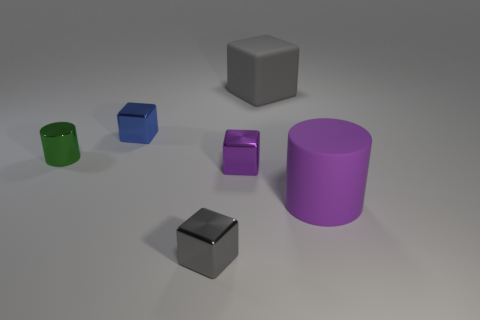Compared to the other objects, where is the green cylinder located? The green cylinder in the image is positioned on the left-hand side. It is closest to the foreground when compared to the other objects, and it is situated directly to the left of the small purple metallic cube. How would you describe its size in relation to the other objects? The green cylinder is medium-sized when compared to the other objects. It is smaller than the purple cylindrical shape and the large blue cube, yet noticeably larger than both the small purple metallic cube and the smaller metal cube at the image's center. 